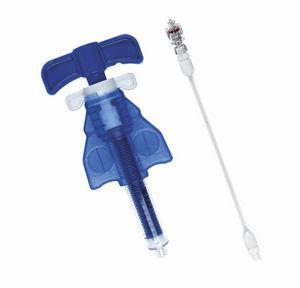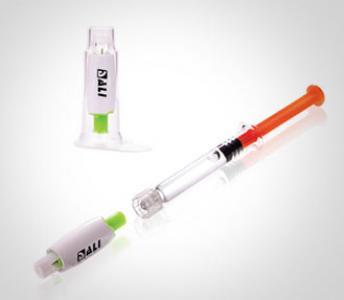The first image is the image on the left, the second image is the image on the right. For the images shown, is this caption "3 syringes are pointed to the left." true? Answer yes or no. No. 